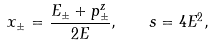<formula> <loc_0><loc_0><loc_500><loc_500>x _ { \pm } = \frac { E _ { \pm } + p ^ { z } _ { \pm } } { 2 E } , \quad s = 4 E ^ { 2 } ,</formula> 